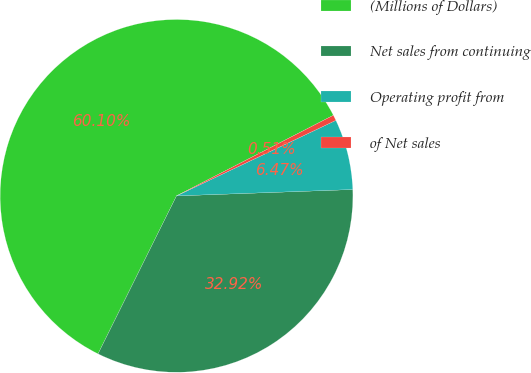Convert chart to OTSL. <chart><loc_0><loc_0><loc_500><loc_500><pie_chart><fcel>(Millions of Dollars)<fcel>Net sales from continuing<fcel>Operating profit from<fcel>of Net sales<nl><fcel>60.11%<fcel>32.92%<fcel>6.47%<fcel>0.51%<nl></chart> 